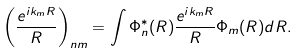<formula> <loc_0><loc_0><loc_500><loc_500>\left ( \frac { e ^ { i k _ { m } R } } { R } \right ) _ { n m } = \int \Phi _ { n } ^ { * } ( R ) \frac { e ^ { i k _ { m } R } } { R } \Phi _ { m } ( R ) d R .</formula> 